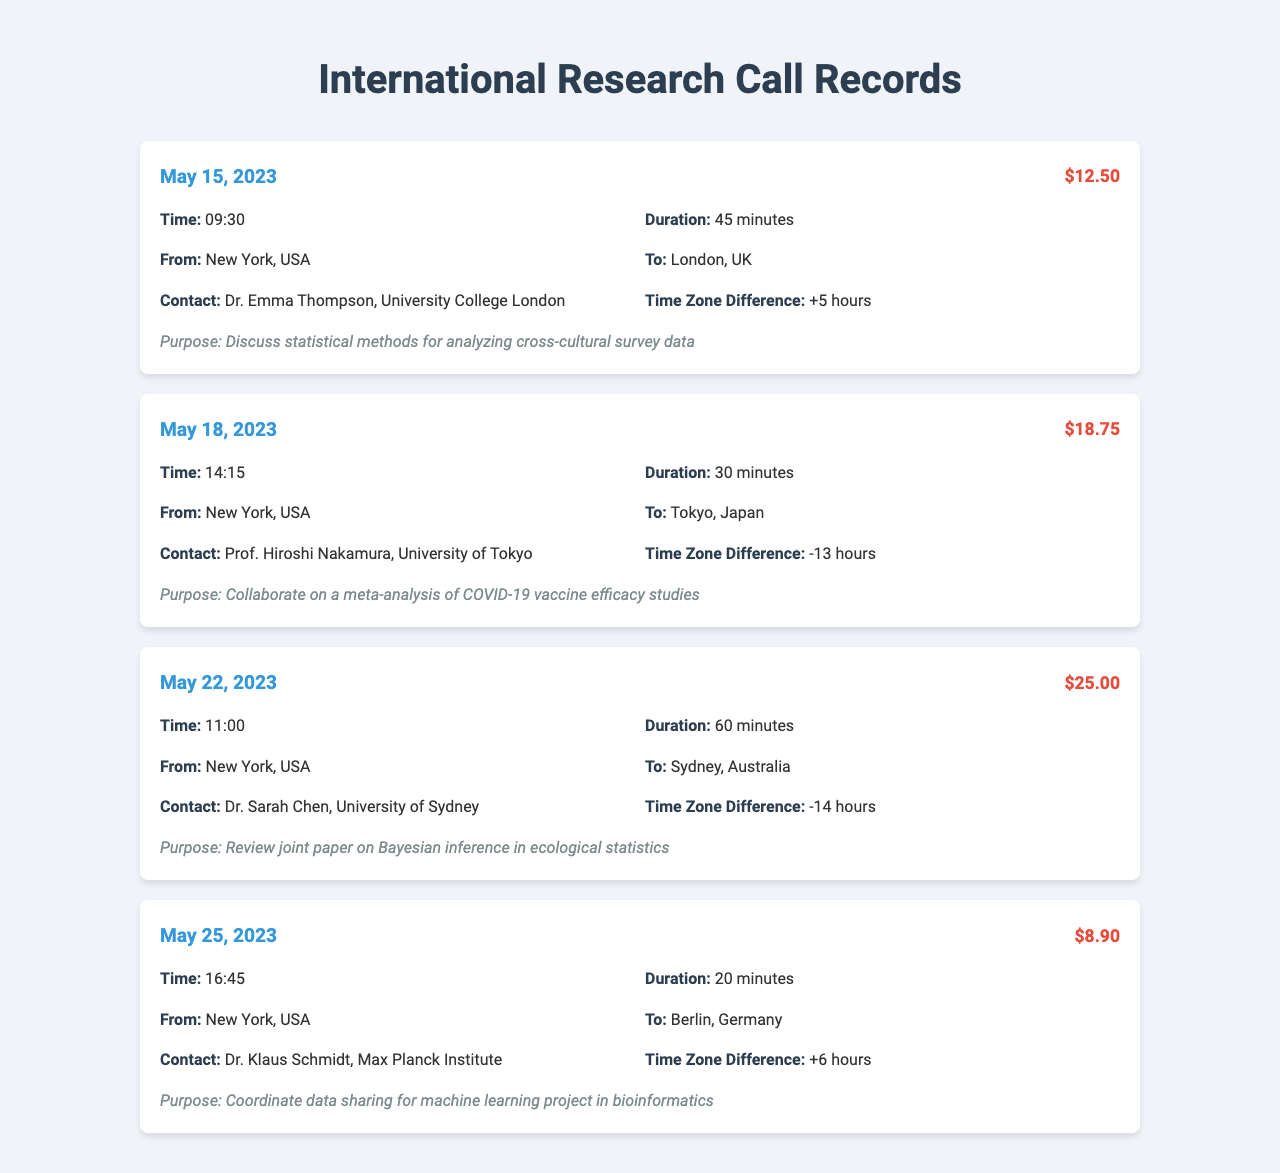what was the cost of the call to Tokyo? The cost of the call to Tokyo, Japan on May 18, 2023, is specified in the document.
Answer: $18.75 who did the call to Berlin involve? The document lists the contact person for the call to Berlin, Germany on May 25, 2023.
Answer: Dr. Klaus Schmidt how long was the call to Sydney? The duration of the call to Sydney, Australia on May 22, 2023, is recorded in the document.
Answer: 60 minutes what was the purpose of the call to London? The document describes the purpose of the call to London, UK on May 15, 2023.
Answer: Discuss statistical methods for analyzing cross-cultural survey data which call had the highest cost? By reviewing the call costs in the document, we can identify the most expensive call listed.
Answer: $25.00 how many hours is the time zone difference for the call to Berlin? The time zone difference for the Berlin call is indicated in the document.
Answer: +6 hours what city was the call to on May 18, 2023? The document specifies the destination of the call made on May 18, 2023.
Answer: Tokyo, Japan what was the duration of the shortest call? We can determine the shortest call by comparing the durations noted in the document.
Answer: 20 minutes 